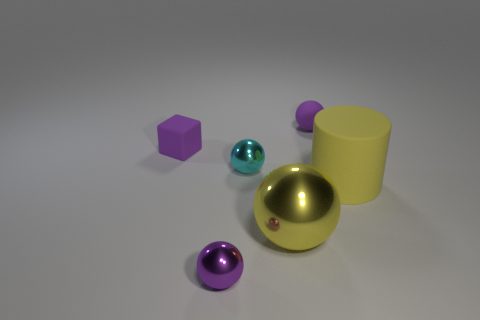Do the large metal thing and the matte cylinder have the same color?
Your answer should be compact. Yes. What is the size of the matte block that is the same color as the tiny matte sphere?
Make the answer very short. Small. There is a small purple sphere that is in front of the thing that is right of the rubber thing behind the purple cube; what is it made of?
Provide a short and direct response. Metal. There is a cylinder that is the same color as the large sphere; what material is it?
Give a very brief answer. Rubber. Does the cube that is to the left of the large ball have the same color as the small metallic ball behind the big yellow matte cylinder?
Your answer should be very brief. No. There is a tiny purple thing in front of the tiny thing on the left side of the small thing in front of the tiny cyan metallic sphere; what shape is it?
Offer a terse response. Sphere. There is a thing that is on the left side of the large cylinder and right of the large sphere; what shape is it?
Provide a short and direct response. Sphere. There is a small purple object that is on the right side of the purple sphere in front of the cylinder; what number of tiny purple rubber things are behind it?
Make the answer very short. 0. There is a rubber object that is the same shape as the small cyan metal thing; what is its size?
Your response must be concise. Small. Does the large object to the left of the big matte object have the same material as the block?
Your answer should be compact. No. 